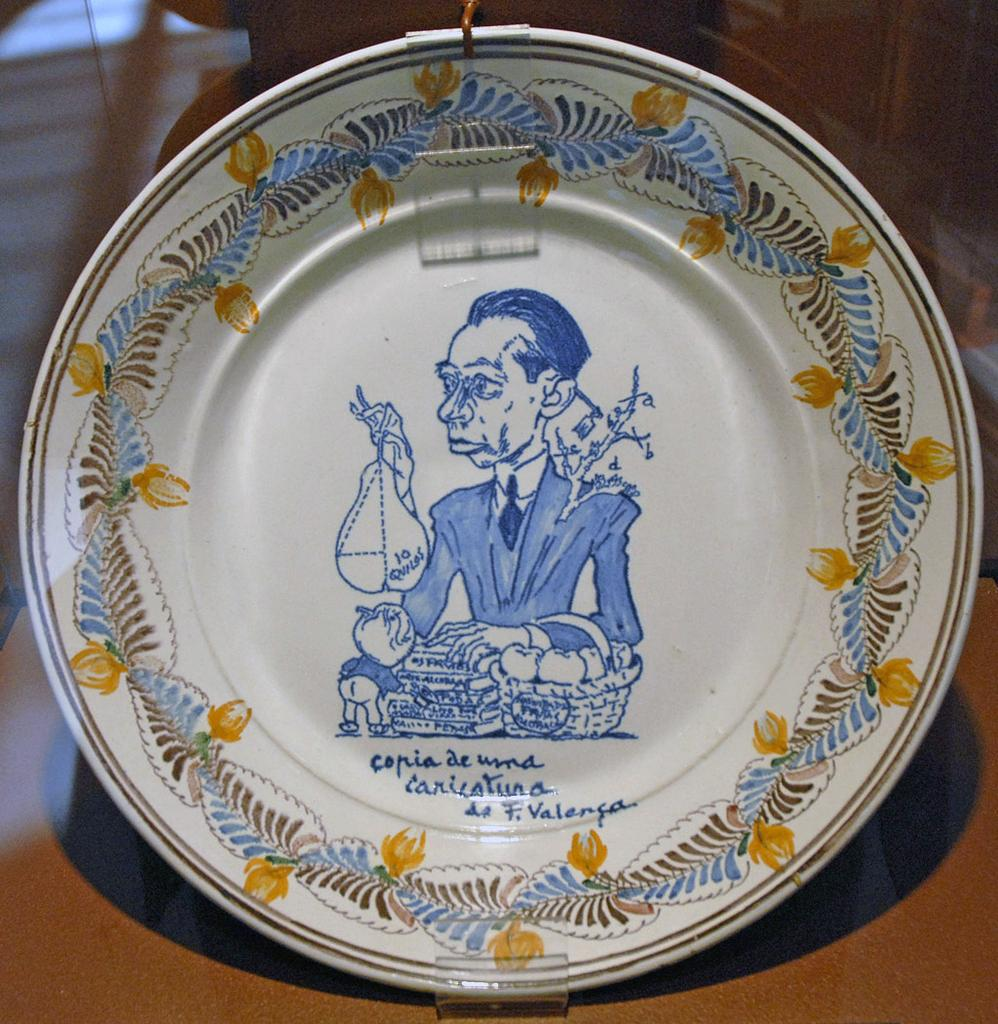What object is visible in the image that is typically used for serving food? There is a plate in the image. Where is the plate located in the image? The plate is placed over a surface. What is depicted on the plate? There is a picture and text on the plate. What else can be seen on the plate besides the picture and text? There is a design around the picture and text on the plate. What type of veil can be seen covering the plate in the image? There is no veil present in the image; the plate is visible and not covered. 